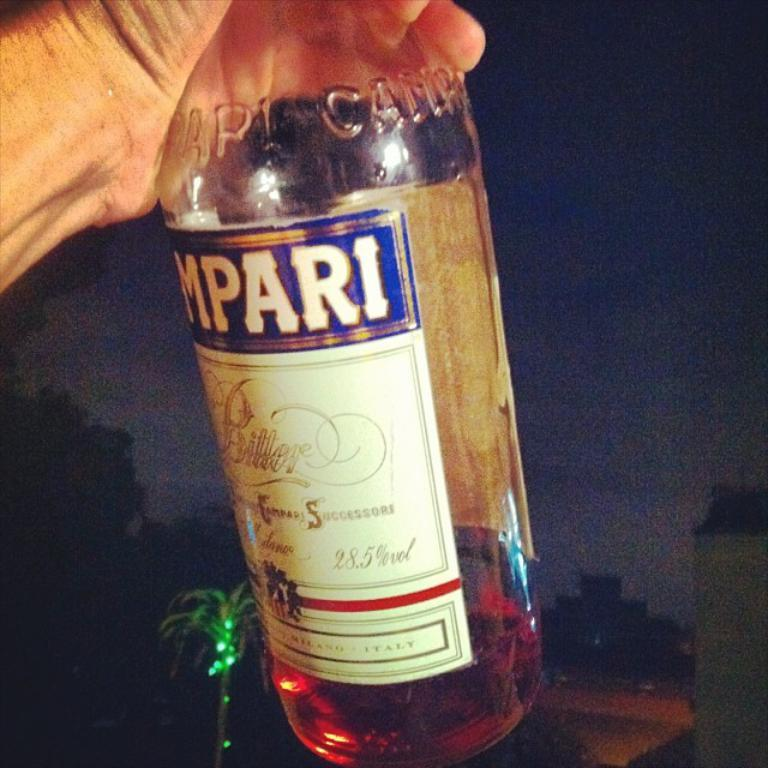<image>
Summarize the visual content of the image. A bottle of alcohol that has a volume of 28.5 percent. 